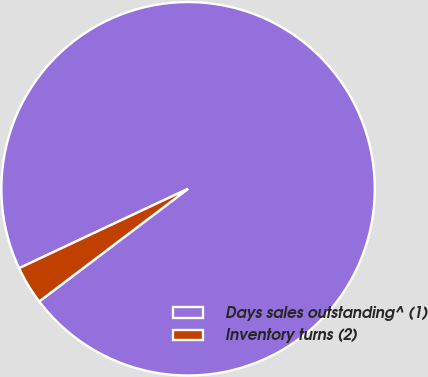Convert chart to OTSL. <chart><loc_0><loc_0><loc_500><loc_500><pie_chart><fcel>Days sales outstanding^ (1)<fcel>Inventory turns (2)<nl><fcel>96.68%<fcel>3.32%<nl></chart> 